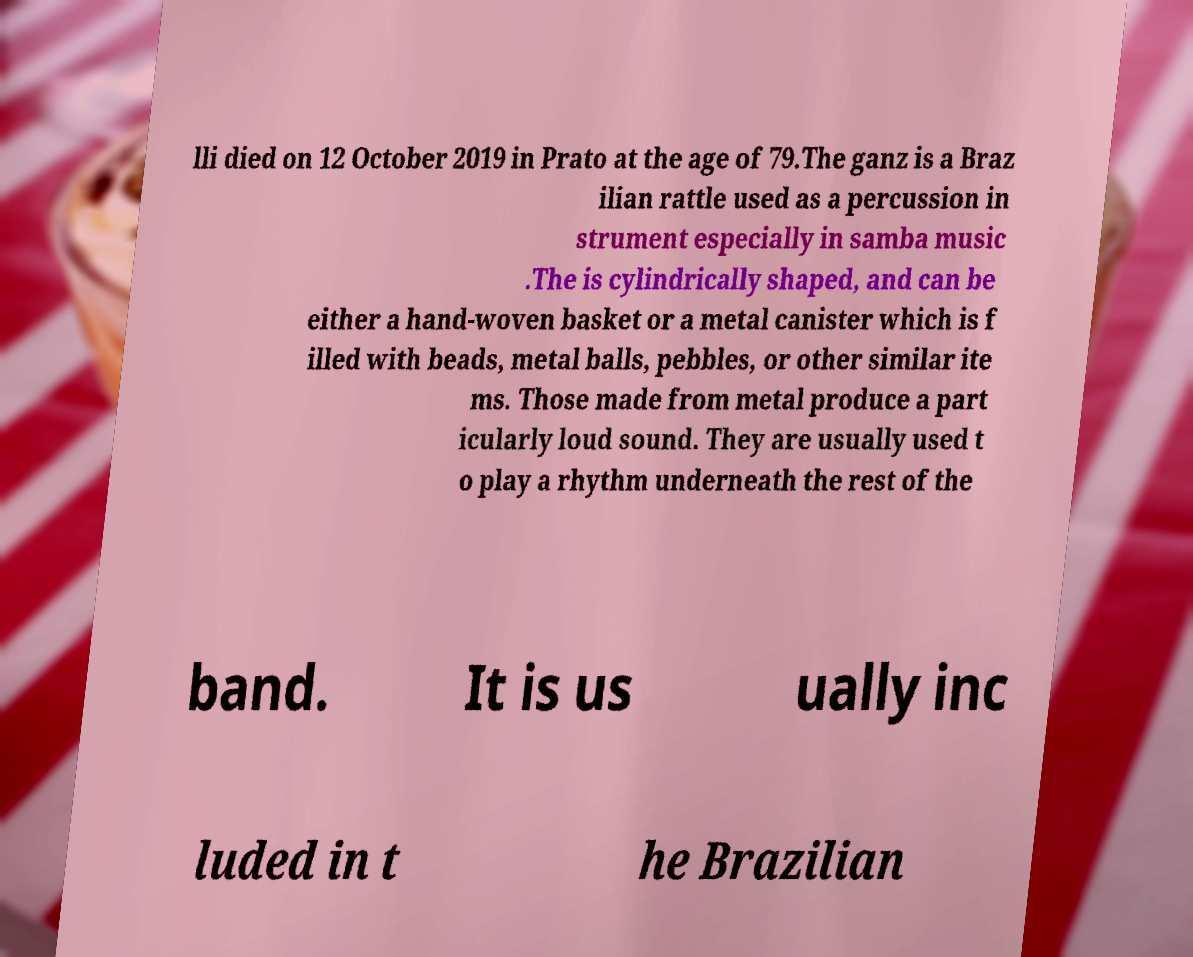I need the written content from this picture converted into text. Can you do that? lli died on 12 October 2019 in Prato at the age of 79.The ganz is a Braz ilian rattle used as a percussion in strument especially in samba music .The is cylindrically shaped, and can be either a hand-woven basket or a metal canister which is f illed with beads, metal balls, pebbles, or other similar ite ms. Those made from metal produce a part icularly loud sound. They are usually used t o play a rhythm underneath the rest of the band. It is us ually inc luded in t he Brazilian 